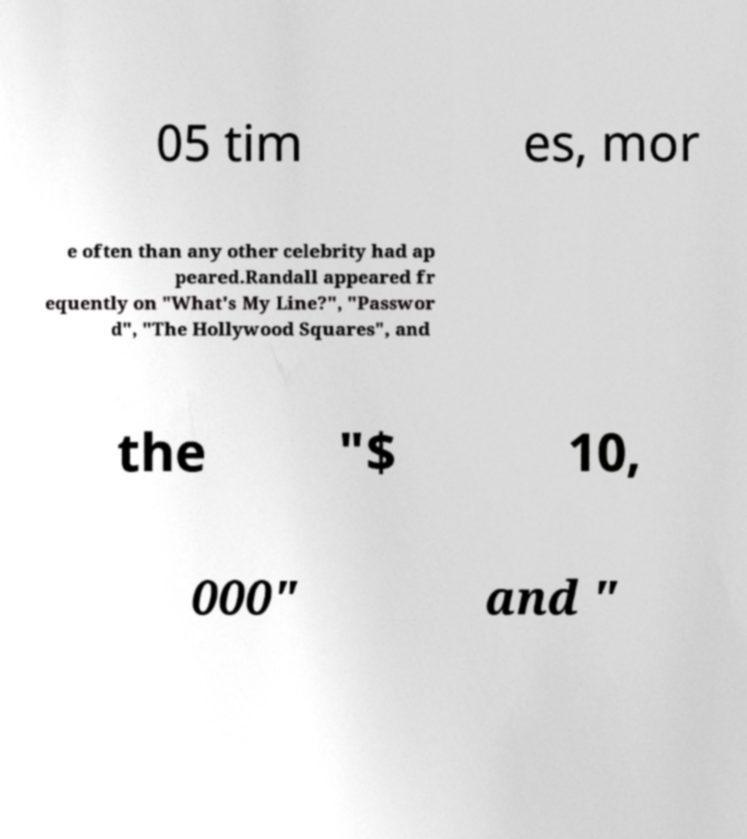Could you assist in decoding the text presented in this image and type it out clearly? 05 tim es, mor e often than any other celebrity had ap peared.Randall appeared fr equently on "What's My Line?", "Passwor d", "The Hollywood Squares", and the "$ 10, 000" and " 